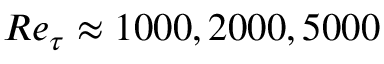Convert formula to latex. <formula><loc_0><loc_0><loc_500><loc_500>R e _ { \tau } \approx 1 0 0 0 , 2 0 0 0 , 5 0 0 0</formula> 